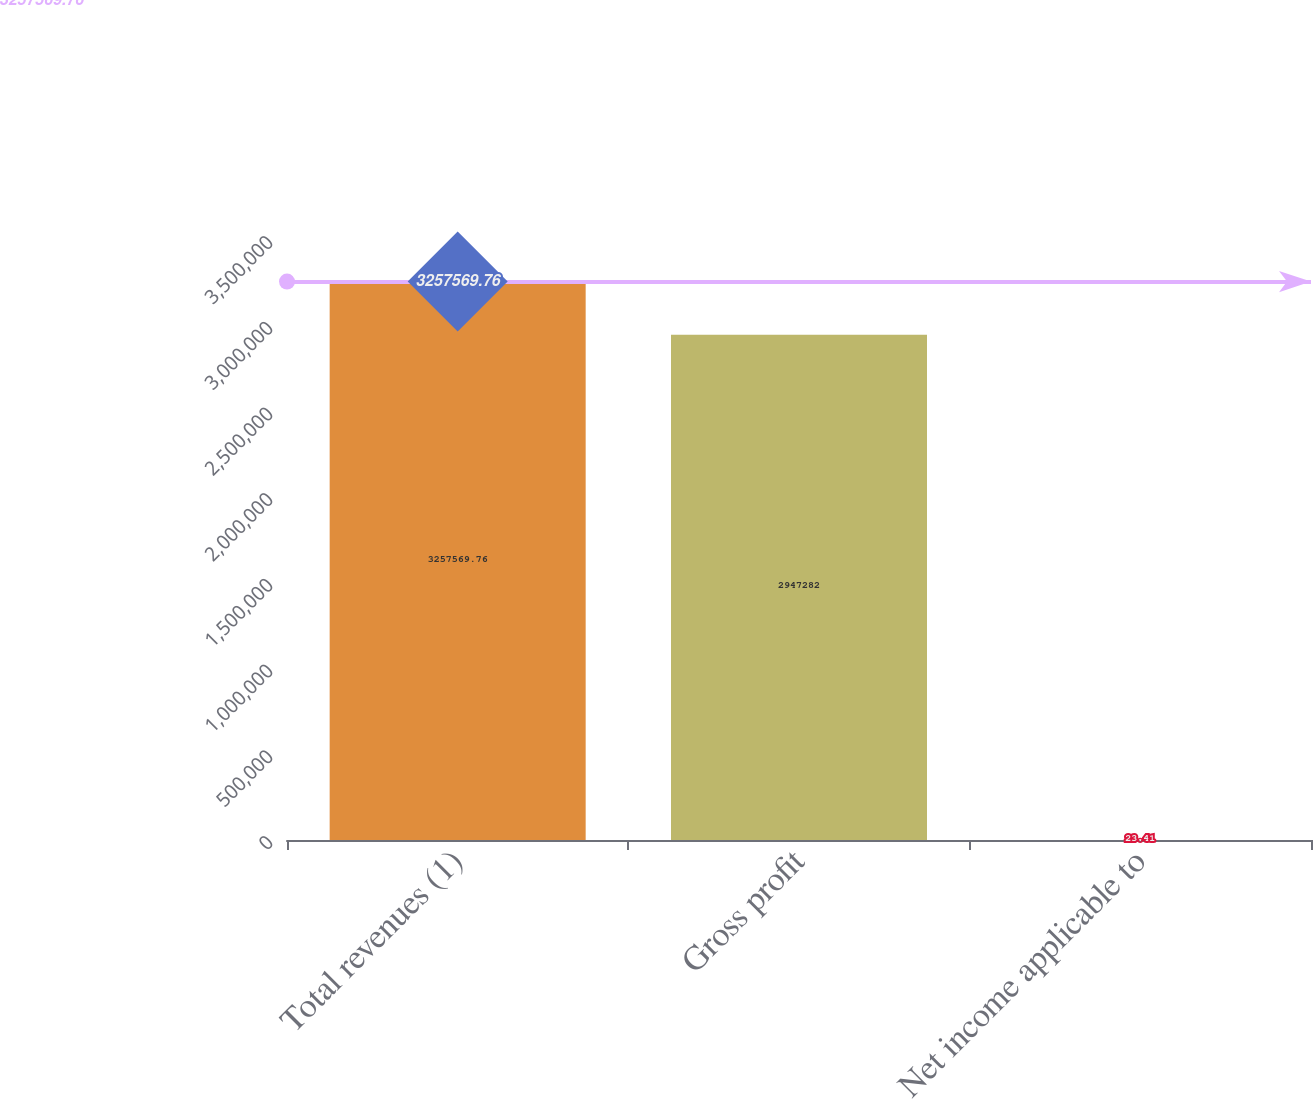Convert chart to OTSL. <chart><loc_0><loc_0><loc_500><loc_500><bar_chart><fcel>Total revenues (1)<fcel>Gross profit<fcel>Net income applicable to<nl><fcel>3.25757e+06<fcel>2.94728e+06<fcel>23.41<nl></chart> 